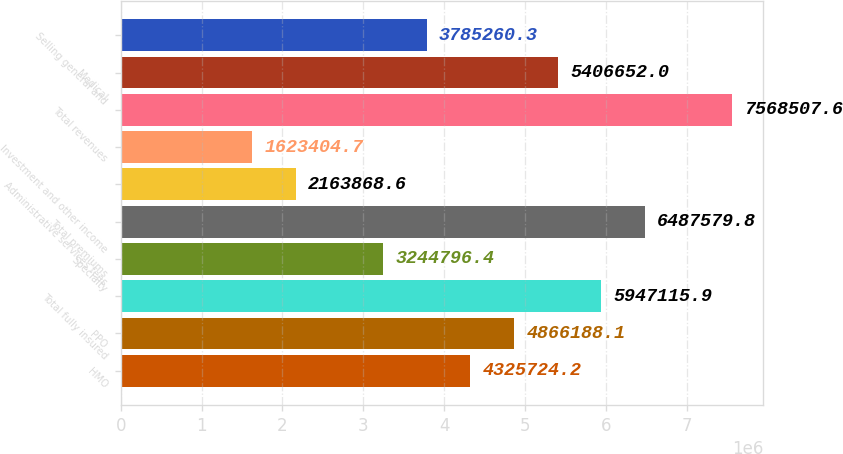Convert chart to OTSL. <chart><loc_0><loc_0><loc_500><loc_500><bar_chart><fcel>HMO<fcel>PPO<fcel>Total fully insured<fcel>Specialty<fcel>Total premiums<fcel>Administrative services fees<fcel>Investment and other income<fcel>Total revenues<fcel>Medical<fcel>Selling general and<nl><fcel>4.32572e+06<fcel>4.86619e+06<fcel>5.94712e+06<fcel>3.2448e+06<fcel>6.48758e+06<fcel>2.16387e+06<fcel>1.6234e+06<fcel>7.56851e+06<fcel>5.40665e+06<fcel>3.78526e+06<nl></chart> 